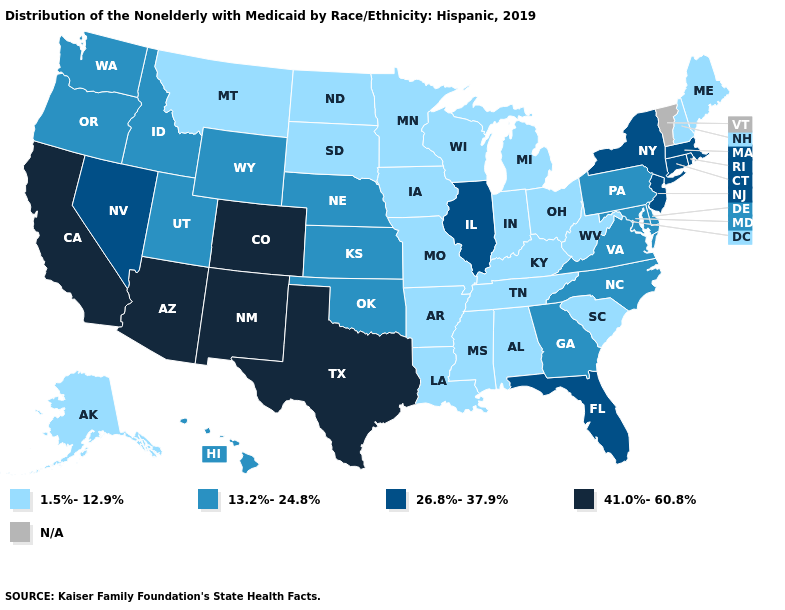What is the value of Tennessee?
Write a very short answer. 1.5%-12.9%. How many symbols are there in the legend?
Concise answer only. 5. What is the value of South Carolina?
Answer briefly. 1.5%-12.9%. Which states have the lowest value in the USA?
Write a very short answer. Alabama, Alaska, Arkansas, Indiana, Iowa, Kentucky, Louisiana, Maine, Michigan, Minnesota, Mississippi, Missouri, Montana, New Hampshire, North Dakota, Ohio, South Carolina, South Dakota, Tennessee, West Virginia, Wisconsin. What is the value of Arizona?
Write a very short answer. 41.0%-60.8%. Which states hav the highest value in the South?
Keep it brief. Texas. Name the states that have a value in the range 13.2%-24.8%?
Give a very brief answer. Delaware, Georgia, Hawaii, Idaho, Kansas, Maryland, Nebraska, North Carolina, Oklahoma, Oregon, Pennsylvania, Utah, Virginia, Washington, Wyoming. What is the value of Nebraska?
Be succinct. 13.2%-24.8%. Is the legend a continuous bar?
Concise answer only. No. Among the states that border Florida , does Georgia have the lowest value?
Concise answer only. No. Name the states that have a value in the range 1.5%-12.9%?
Short answer required. Alabama, Alaska, Arkansas, Indiana, Iowa, Kentucky, Louisiana, Maine, Michigan, Minnesota, Mississippi, Missouri, Montana, New Hampshire, North Dakota, Ohio, South Carolina, South Dakota, Tennessee, West Virginia, Wisconsin. Does the first symbol in the legend represent the smallest category?
Quick response, please. Yes. Is the legend a continuous bar?
Write a very short answer. No. 